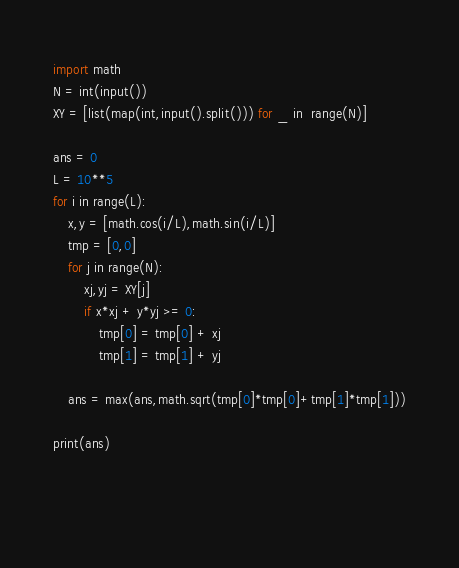Convert code to text. <code><loc_0><loc_0><loc_500><loc_500><_Python_>
import math
N = int(input())
XY = [list(map(int,input().split())) for _ in  range(N)]

ans = 0
L = 10**5
for i in range(L):
    x,y = [math.cos(i/L),math.sin(i/L)]
    tmp = [0,0]
    for j in range(N):
        xj,yj = XY[j]
        if x*xj + y*yj >= 0:
            tmp[0] = tmp[0] + xj
            tmp[1] = tmp[1] + yj
            
    ans = max(ans,math.sqrt(tmp[0]*tmp[0]+tmp[1]*tmp[1]))
    
print(ans)
            
    
    </code> 